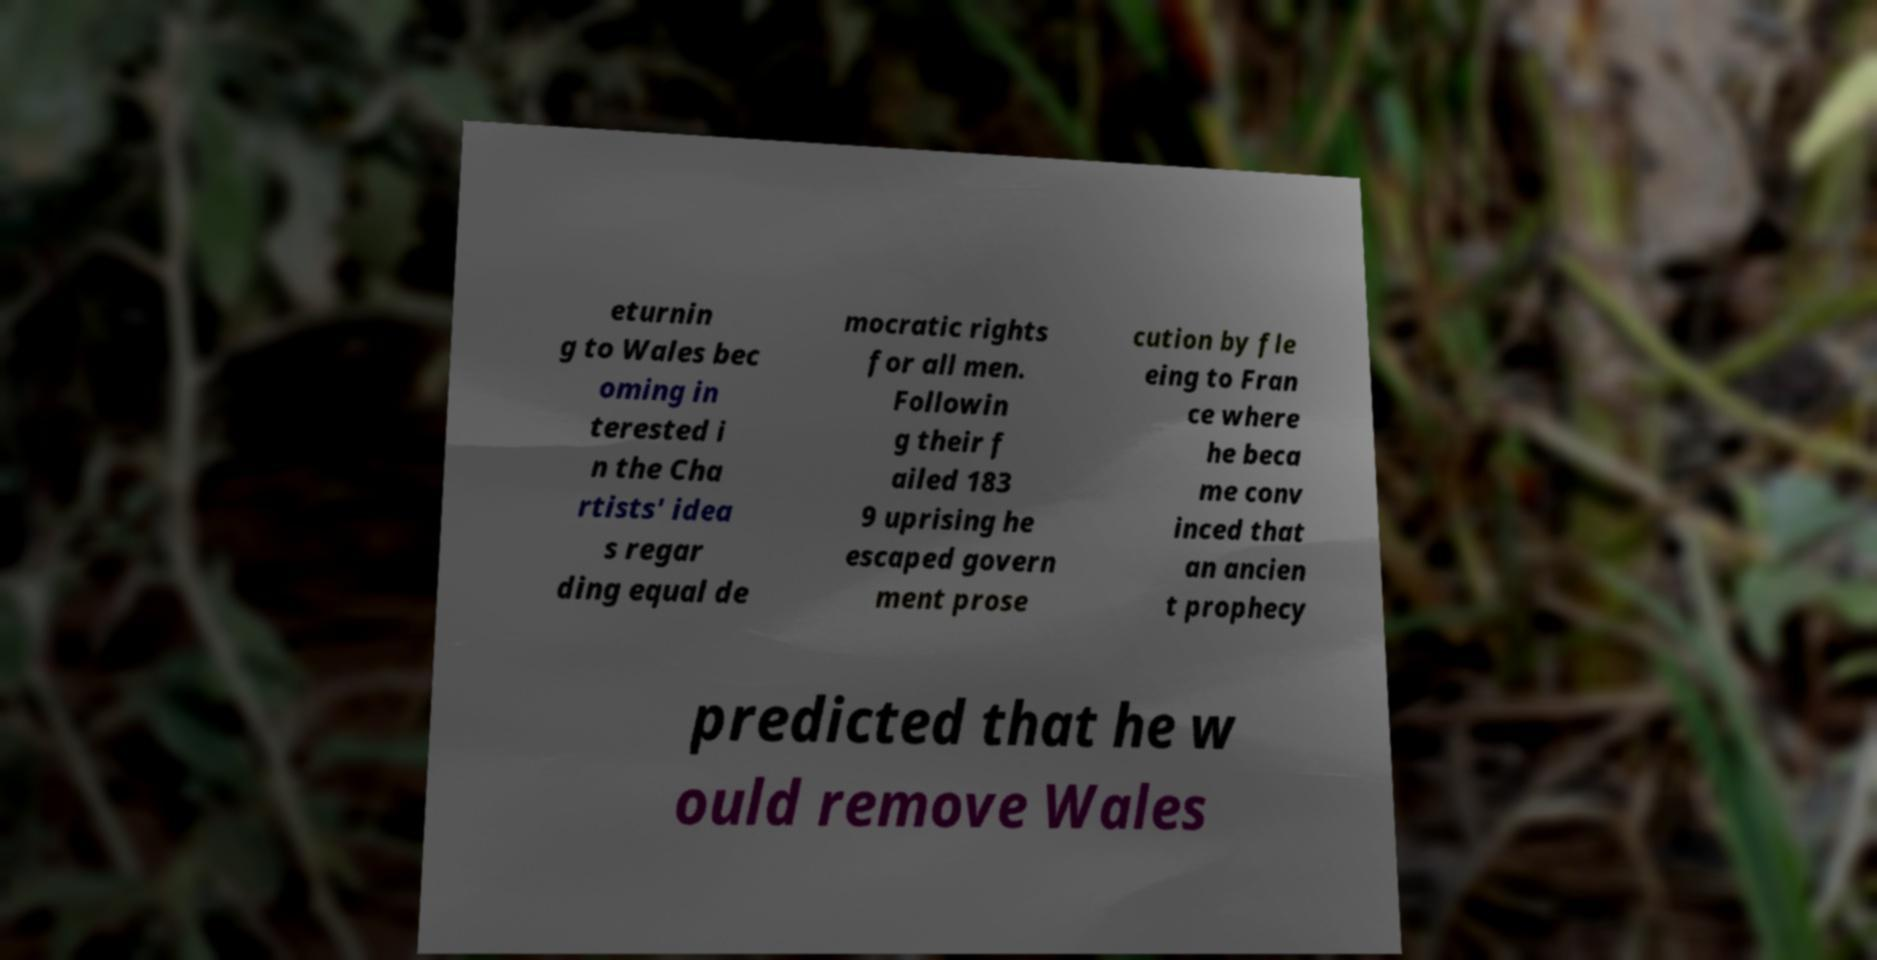Could you extract and type out the text from this image? eturnin g to Wales bec oming in terested i n the Cha rtists' idea s regar ding equal de mocratic rights for all men. Followin g their f ailed 183 9 uprising he escaped govern ment prose cution by fle eing to Fran ce where he beca me conv inced that an ancien t prophecy predicted that he w ould remove Wales 